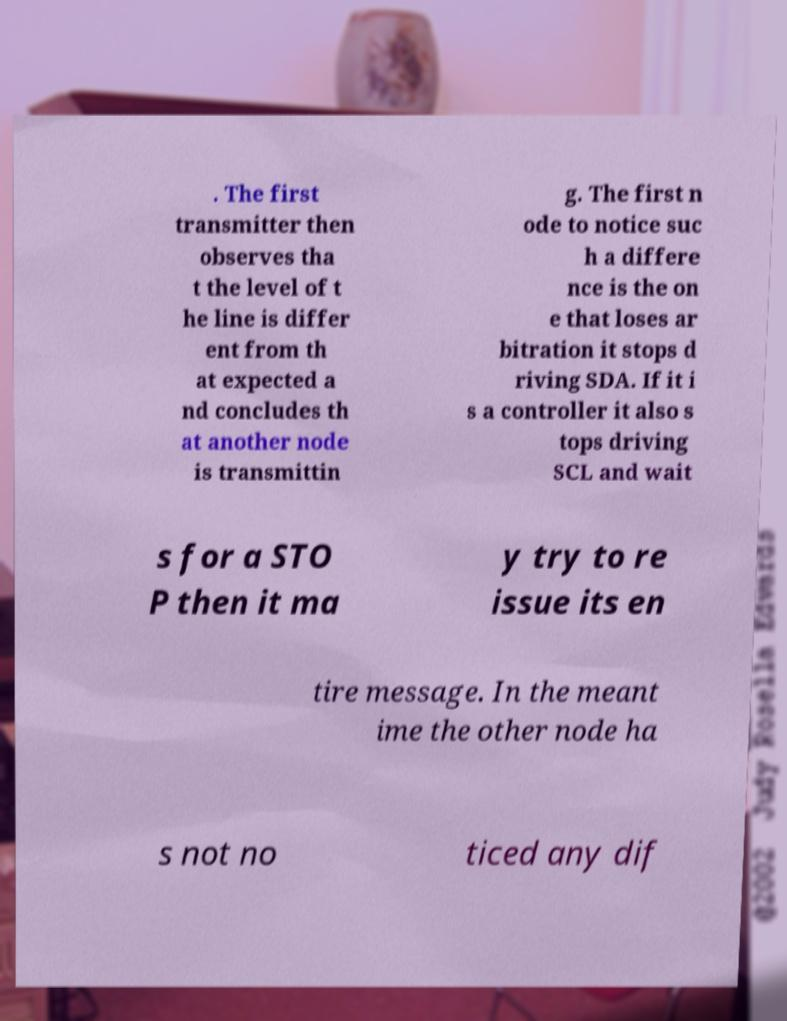Could you assist in decoding the text presented in this image and type it out clearly? . The first transmitter then observes tha t the level of t he line is differ ent from th at expected a nd concludes th at another node is transmittin g. The first n ode to notice suc h a differe nce is the on e that loses ar bitration it stops d riving SDA. If it i s a controller it also s tops driving SCL and wait s for a STO P then it ma y try to re issue its en tire message. In the meant ime the other node ha s not no ticed any dif 